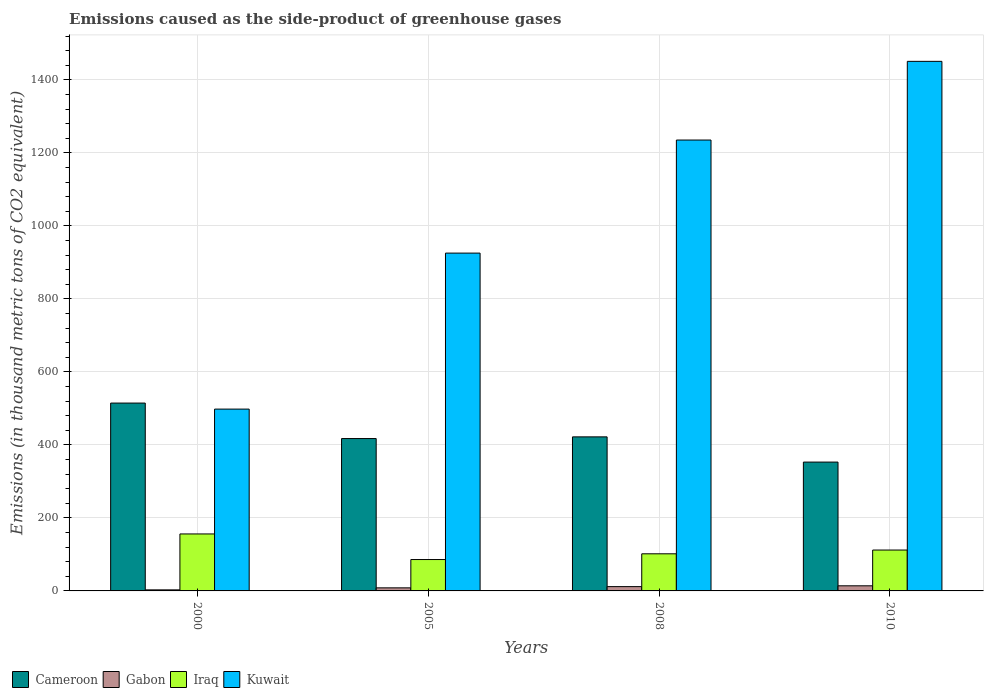How many groups of bars are there?
Make the answer very short. 4. Are the number of bars per tick equal to the number of legend labels?
Offer a very short reply. Yes. Across all years, what is the maximum emissions caused as the side-product of greenhouse gases in Iraq?
Offer a very short reply. 156.1. Across all years, what is the minimum emissions caused as the side-product of greenhouse gases in Cameroon?
Keep it short and to the point. 353. What is the total emissions caused as the side-product of greenhouse gases in Kuwait in the graph?
Your answer should be compact. 4110.2. What is the difference between the emissions caused as the side-product of greenhouse gases in Cameroon in 2008 and that in 2010?
Your response must be concise. 69.1. What is the difference between the emissions caused as the side-product of greenhouse gases in Iraq in 2000 and the emissions caused as the side-product of greenhouse gases in Gabon in 2010?
Provide a succinct answer. 142.1. What is the average emissions caused as the side-product of greenhouse gases in Kuwait per year?
Keep it short and to the point. 1027.55. In the year 2005, what is the difference between the emissions caused as the side-product of greenhouse gases in Iraq and emissions caused as the side-product of greenhouse gases in Kuwait?
Make the answer very short. -839.6. In how many years, is the emissions caused as the side-product of greenhouse gases in Iraq greater than 1280 thousand metric tons?
Your answer should be very brief. 0. What is the ratio of the emissions caused as the side-product of greenhouse gases in Iraq in 2000 to that in 2005?
Offer a terse response. 1.82. Is the emissions caused as the side-product of greenhouse gases in Gabon in 2000 less than that in 2005?
Offer a very short reply. Yes. What is the difference between the highest and the second highest emissions caused as the side-product of greenhouse gases in Gabon?
Ensure brevity in your answer.  2.2. What is the difference between the highest and the lowest emissions caused as the side-product of greenhouse gases in Gabon?
Your answer should be very brief. 11.1. In how many years, is the emissions caused as the side-product of greenhouse gases in Gabon greater than the average emissions caused as the side-product of greenhouse gases in Gabon taken over all years?
Offer a very short reply. 2. Is the sum of the emissions caused as the side-product of greenhouse gases in Iraq in 2000 and 2005 greater than the maximum emissions caused as the side-product of greenhouse gases in Cameroon across all years?
Provide a short and direct response. No. What does the 1st bar from the left in 2000 represents?
Your answer should be very brief. Cameroon. What does the 2nd bar from the right in 2005 represents?
Your answer should be compact. Iraq. How many years are there in the graph?
Your answer should be very brief. 4. Are the values on the major ticks of Y-axis written in scientific E-notation?
Give a very brief answer. No. Does the graph contain grids?
Provide a succinct answer. Yes. How are the legend labels stacked?
Your answer should be compact. Horizontal. What is the title of the graph?
Ensure brevity in your answer.  Emissions caused as the side-product of greenhouse gases. What is the label or title of the X-axis?
Your answer should be compact. Years. What is the label or title of the Y-axis?
Ensure brevity in your answer.  Emissions (in thousand metric tons of CO2 equivalent). What is the Emissions (in thousand metric tons of CO2 equivalent) of Cameroon in 2000?
Your response must be concise. 514.7. What is the Emissions (in thousand metric tons of CO2 equivalent) of Gabon in 2000?
Give a very brief answer. 2.9. What is the Emissions (in thousand metric tons of CO2 equivalent) in Iraq in 2000?
Keep it short and to the point. 156.1. What is the Emissions (in thousand metric tons of CO2 equivalent) of Kuwait in 2000?
Your answer should be very brief. 498.2. What is the Emissions (in thousand metric tons of CO2 equivalent) of Cameroon in 2005?
Keep it short and to the point. 417.5. What is the Emissions (in thousand metric tons of CO2 equivalent) of Gabon in 2005?
Your answer should be compact. 8.4. What is the Emissions (in thousand metric tons of CO2 equivalent) in Kuwait in 2005?
Make the answer very short. 925.6. What is the Emissions (in thousand metric tons of CO2 equivalent) of Cameroon in 2008?
Ensure brevity in your answer.  422.1. What is the Emissions (in thousand metric tons of CO2 equivalent) in Gabon in 2008?
Your answer should be compact. 11.8. What is the Emissions (in thousand metric tons of CO2 equivalent) of Iraq in 2008?
Provide a succinct answer. 101.7. What is the Emissions (in thousand metric tons of CO2 equivalent) of Kuwait in 2008?
Ensure brevity in your answer.  1235.4. What is the Emissions (in thousand metric tons of CO2 equivalent) in Cameroon in 2010?
Offer a very short reply. 353. What is the Emissions (in thousand metric tons of CO2 equivalent) of Iraq in 2010?
Offer a very short reply. 112. What is the Emissions (in thousand metric tons of CO2 equivalent) of Kuwait in 2010?
Make the answer very short. 1451. Across all years, what is the maximum Emissions (in thousand metric tons of CO2 equivalent) in Cameroon?
Offer a very short reply. 514.7. Across all years, what is the maximum Emissions (in thousand metric tons of CO2 equivalent) in Iraq?
Keep it short and to the point. 156.1. Across all years, what is the maximum Emissions (in thousand metric tons of CO2 equivalent) in Kuwait?
Offer a terse response. 1451. Across all years, what is the minimum Emissions (in thousand metric tons of CO2 equivalent) of Cameroon?
Give a very brief answer. 353. Across all years, what is the minimum Emissions (in thousand metric tons of CO2 equivalent) of Iraq?
Offer a terse response. 86. Across all years, what is the minimum Emissions (in thousand metric tons of CO2 equivalent) in Kuwait?
Provide a succinct answer. 498.2. What is the total Emissions (in thousand metric tons of CO2 equivalent) in Cameroon in the graph?
Your response must be concise. 1707.3. What is the total Emissions (in thousand metric tons of CO2 equivalent) in Gabon in the graph?
Ensure brevity in your answer.  37.1. What is the total Emissions (in thousand metric tons of CO2 equivalent) in Iraq in the graph?
Provide a short and direct response. 455.8. What is the total Emissions (in thousand metric tons of CO2 equivalent) in Kuwait in the graph?
Ensure brevity in your answer.  4110.2. What is the difference between the Emissions (in thousand metric tons of CO2 equivalent) of Cameroon in 2000 and that in 2005?
Offer a terse response. 97.2. What is the difference between the Emissions (in thousand metric tons of CO2 equivalent) of Iraq in 2000 and that in 2005?
Your response must be concise. 70.1. What is the difference between the Emissions (in thousand metric tons of CO2 equivalent) in Kuwait in 2000 and that in 2005?
Your answer should be compact. -427.4. What is the difference between the Emissions (in thousand metric tons of CO2 equivalent) in Cameroon in 2000 and that in 2008?
Offer a very short reply. 92.6. What is the difference between the Emissions (in thousand metric tons of CO2 equivalent) of Gabon in 2000 and that in 2008?
Make the answer very short. -8.9. What is the difference between the Emissions (in thousand metric tons of CO2 equivalent) in Iraq in 2000 and that in 2008?
Offer a very short reply. 54.4. What is the difference between the Emissions (in thousand metric tons of CO2 equivalent) of Kuwait in 2000 and that in 2008?
Your answer should be compact. -737.2. What is the difference between the Emissions (in thousand metric tons of CO2 equivalent) in Cameroon in 2000 and that in 2010?
Offer a very short reply. 161.7. What is the difference between the Emissions (in thousand metric tons of CO2 equivalent) in Gabon in 2000 and that in 2010?
Your response must be concise. -11.1. What is the difference between the Emissions (in thousand metric tons of CO2 equivalent) in Iraq in 2000 and that in 2010?
Your response must be concise. 44.1. What is the difference between the Emissions (in thousand metric tons of CO2 equivalent) of Kuwait in 2000 and that in 2010?
Offer a terse response. -952.8. What is the difference between the Emissions (in thousand metric tons of CO2 equivalent) of Cameroon in 2005 and that in 2008?
Give a very brief answer. -4.6. What is the difference between the Emissions (in thousand metric tons of CO2 equivalent) in Iraq in 2005 and that in 2008?
Make the answer very short. -15.7. What is the difference between the Emissions (in thousand metric tons of CO2 equivalent) in Kuwait in 2005 and that in 2008?
Make the answer very short. -309.8. What is the difference between the Emissions (in thousand metric tons of CO2 equivalent) in Cameroon in 2005 and that in 2010?
Make the answer very short. 64.5. What is the difference between the Emissions (in thousand metric tons of CO2 equivalent) of Iraq in 2005 and that in 2010?
Offer a very short reply. -26. What is the difference between the Emissions (in thousand metric tons of CO2 equivalent) in Kuwait in 2005 and that in 2010?
Your response must be concise. -525.4. What is the difference between the Emissions (in thousand metric tons of CO2 equivalent) of Cameroon in 2008 and that in 2010?
Keep it short and to the point. 69.1. What is the difference between the Emissions (in thousand metric tons of CO2 equivalent) in Gabon in 2008 and that in 2010?
Your response must be concise. -2.2. What is the difference between the Emissions (in thousand metric tons of CO2 equivalent) of Kuwait in 2008 and that in 2010?
Give a very brief answer. -215.6. What is the difference between the Emissions (in thousand metric tons of CO2 equivalent) in Cameroon in 2000 and the Emissions (in thousand metric tons of CO2 equivalent) in Gabon in 2005?
Ensure brevity in your answer.  506.3. What is the difference between the Emissions (in thousand metric tons of CO2 equivalent) of Cameroon in 2000 and the Emissions (in thousand metric tons of CO2 equivalent) of Iraq in 2005?
Offer a very short reply. 428.7. What is the difference between the Emissions (in thousand metric tons of CO2 equivalent) in Cameroon in 2000 and the Emissions (in thousand metric tons of CO2 equivalent) in Kuwait in 2005?
Your answer should be compact. -410.9. What is the difference between the Emissions (in thousand metric tons of CO2 equivalent) of Gabon in 2000 and the Emissions (in thousand metric tons of CO2 equivalent) of Iraq in 2005?
Make the answer very short. -83.1. What is the difference between the Emissions (in thousand metric tons of CO2 equivalent) in Gabon in 2000 and the Emissions (in thousand metric tons of CO2 equivalent) in Kuwait in 2005?
Offer a very short reply. -922.7. What is the difference between the Emissions (in thousand metric tons of CO2 equivalent) of Iraq in 2000 and the Emissions (in thousand metric tons of CO2 equivalent) of Kuwait in 2005?
Provide a short and direct response. -769.5. What is the difference between the Emissions (in thousand metric tons of CO2 equivalent) of Cameroon in 2000 and the Emissions (in thousand metric tons of CO2 equivalent) of Gabon in 2008?
Your answer should be compact. 502.9. What is the difference between the Emissions (in thousand metric tons of CO2 equivalent) of Cameroon in 2000 and the Emissions (in thousand metric tons of CO2 equivalent) of Iraq in 2008?
Your answer should be very brief. 413. What is the difference between the Emissions (in thousand metric tons of CO2 equivalent) in Cameroon in 2000 and the Emissions (in thousand metric tons of CO2 equivalent) in Kuwait in 2008?
Make the answer very short. -720.7. What is the difference between the Emissions (in thousand metric tons of CO2 equivalent) in Gabon in 2000 and the Emissions (in thousand metric tons of CO2 equivalent) in Iraq in 2008?
Your answer should be very brief. -98.8. What is the difference between the Emissions (in thousand metric tons of CO2 equivalent) of Gabon in 2000 and the Emissions (in thousand metric tons of CO2 equivalent) of Kuwait in 2008?
Keep it short and to the point. -1232.5. What is the difference between the Emissions (in thousand metric tons of CO2 equivalent) in Iraq in 2000 and the Emissions (in thousand metric tons of CO2 equivalent) in Kuwait in 2008?
Your response must be concise. -1079.3. What is the difference between the Emissions (in thousand metric tons of CO2 equivalent) of Cameroon in 2000 and the Emissions (in thousand metric tons of CO2 equivalent) of Gabon in 2010?
Provide a succinct answer. 500.7. What is the difference between the Emissions (in thousand metric tons of CO2 equivalent) in Cameroon in 2000 and the Emissions (in thousand metric tons of CO2 equivalent) in Iraq in 2010?
Keep it short and to the point. 402.7. What is the difference between the Emissions (in thousand metric tons of CO2 equivalent) of Cameroon in 2000 and the Emissions (in thousand metric tons of CO2 equivalent) of Kuwait in 2010?
Your answer should be very brief. -936.3. What is the difference between the Emissions (in thousand metric tons of CO2 equivalent) in Gabon in 2000 and the Emissions (in thousand metric tons of CO2 equivalent) in Iraq in 2010?
Provide a succinct answer. -109.1. What is the difference between the Emissions (in thousand metric tons of CO2 equivalent) of Gabon in 2000 and the Emissions (in thousand metric tons of CO2 equivalent) of Kuwait in 2010?
Offer a terse response. -1448.1. What is the difference between the Emissions (in thousand metric tons of CO2 equivalent) of Iraq in 2000 and the Emissions (in thousand metric tons of CO2 equivalent) of Kuwait in 2010?
Ensure brevity in your answer.  -1294.9. What is the difference between the Emissions (in thousand metric tons of CO2 equivalent) in Cameroon in 2005 and the Emissions (in thousand metric tons of CO2 equivalent) in Gabon in 2008?
Offer a terse response. 405.7. What is the difference between the Emissions (in thousand metric tons of CO2 equivalent) of Cameroon in 2005 and the Emissions (in thousand metric tons of CO2 equivalent) of Iraq in 2008?
Offer a very short reply. 315.8. What is the difference between the Emissions (in thousand metric tons of CO2 equivalent) in Cameroon in 2005 and the Emissions (in thousand metric tons of CO2 equivalent) in Kuwait in 2008?
Your answer should be compact. -817.9. What is the difference between the Emissions (in thousand metric tons of CO2 equivalent) in Gabon in 2005 and the Emissions (in thousand metric tons of CO2 equivalent) in Iraq in 2008?
Provide a succinct answer. -93.3. What is the difference between the Emissions (in thousand metric tons of CO2 equivalent) in Gabon in 2005 and the Emissions (in thousand metric tons of CO2 equivalent) in Kuwait in 2008?
Your answer should be compact. -1227. What is the difference between the Emissions (in thousand metric tons of CO2 equivalent) of Iraq in 2005 and the Emissions (in thousand metric tons of CO2 equivalent) of Kuwait in 2008?
Your answer should be very brief. -1149.4. What is the difference between the Emissions (in thousand metric tons of CO2 equivalent) of Cameroon in 2005 and the Emissions (in thousand metric tons of CO2 equivalent) of Gabon in 2010?
Your answer should be compact. 403.5. What is the difference between the Emissions (in thousand metric tons of CO2 equivalent) in Cameroon in 2005 and the Emissions (in thousand metric tons of CO2 equivalent) in Iraq in 2010?
Make the answer very short. 305.5. What is the difference between the Emissions (in thousand metric tons of CO2 equivalent) of Cameroon in 2005 and the Emissions (in thousand metric tons of CO2 equivalent) of Kuwait in 2010?
Your answer should be compact. -1033.5. What is the difference between the Emissions (in thousand metric tons of CO2 equivalent) of Gabon in 2005 and the Emissions (in thousand metric tons of CO2 equivalent) of Iraq in 2010?
Your answer should be very brief. -103.6. What is the difference between the Emissions (in thousand metric tons of CO2 equivalent) in Gabon in 2005 and the Emissions (in thousand metric tons of CO2 equivalent) in Kuwait in 2010?
Offer a very short reply. -1442.6. What is the difference between the Emissions (in thousand metric tons of CO2 equivalent) of Iraq in 2005 and the Emissions (in thousand metric tons of CO2 equivalent) of Kuwait in 2010?
Provide a short and direct response. -1365. What is the difference between the Emissions (in thousand metric tons of CO2 equivalent) in Cameroon in 2008 and the Emissions (in thousand metric tons of CO2 equivalent) in Gabon in 2010?
Keep it short and to the point. 408.1. What is the difference between the Emissions (in thousand metric tons of CO2 equivalent) in Cameroon in 2008 and the Emissions (in thousand metric tons of CO2 equivalent) in Iraq in 2010?
Your answer should be compact. 310.1. What is the difference between the Emissions (in thousand metric tons of CO2 equivalent) of Cameroon in 2008 and the Emissions (in thousand metric tons of CO2 equivalent) of Kuwait in 2010?
Provide a succinct answer. -1028.9. What is the difference between the Emissions (in thousand metric tons of CO2 equivalent) in Gabon in 2008 and the Emissions (in thousand metric tons of CO2 equivalent) in Iraq in 2010?
Your answer should be compact. -100.2. What is the difference between the Emissions (in thousand metric tons of CO2 equivalent) in Gabon in 2008 and the Emissions (in thousand metric tons of CO2 equivalent) in Kuwait in 2010?
Offer a terse response. -1439.2. What is the difference between the Emissions (in thousand metric tons of CO2 equivalent) of Iraq in 2008 and the Emissions (in thousand metric tons of CO2 equivalent) of Kuwait in 2010?
Provide a short and direct response. -1349.3. What is the average Emissions (in thousand metric tons of CO2 equivalent) of Cameroon per year?
Your response must be concise. 426.82. What is the average Emissions (in thousand metric tons of CO2 equivalent) in Gabon per year?
Keep it short and to the point. 9.28. What is the average Emissions (in thousand metric tons of CO2 equivalent) in Iraq per year?
Ensure brevity in your answer.  113.95. What is the average Emissions (in thousand metric tons of CO2 equivalent) in Kuwait per year?
Keep it short and to the point. 1027.55. In the year 2000, what is the difference between the Emissions (in thousand metric tons of CO2 equivalent) of Cameroon and Emissions (in thousand metric tons of CO2 equivalent) of Gabon?
Your response must be concise. 511.8. In the year 2000, what is the difference between the Emissions (in thousand metric tons of CO2 equivalent) of Cameroon and Emissions (in thousand metric tons of CO2 equivalent) of Iraq?
Ensure brevity in your answer.  358.6. In the year 2000, what is the difference between the Emissions (in thousand metric tons of CO2 equivalent) of Cameroon and Emissions (in thousand metric tons of CO2 equivalent) of Kuwait?
Ensure brevity in your answer.  16.5. In the year 2000, what is the difference between the Emissions (in thousand metric tons of CO2 equivalent) in Gabon and Emissions (in thousand metric tons of CO2 equivalent) in Iraq?
Your answer should be very brief. -153.2. In the year 2000, what is the difference between the Emissions (in thousand metric tons of CO2 equivalent) of Gabon and Emissions (in thousand metric tons of CO2 equivalent) of Kuwait?
Your answer should be compact. -495.3. In the year 2000, what is the difference between the Emissions (in thousand metric tons of CO2 equivalent) of Iraq and Emissions (in thousand metric tons of CO2 equivalent) of Kuwait?
Keep it short and to the point. -342.1. In the year 2005, what is the difference between the Emissions (in thousand metric tons of CO2 equivalent) of Cameroon and Emissions (in thousand metric tons of CO2 equivalent) of Gabon?
Provide a short and direct response. 409.1. In the year 2005, what is the difference between the Emissions (in thousand metric tons of CO2 equivalent) of Cameroon and Emissions (in thousand metric tons of CO2 equivalent) of Iraq?
Your answer should be very brief. 331.5. In the year 2005, what is the difference between the Emissions (in thousand metric tons of CO2 equivalent) in Cameroon and Emissions (in thousand metric tons of CO2 equivalent) in Kuwait?
Offer a terse response. -508.1. In the year 2005, what is the difference between the Emissions (in thousand metric tons of CO2 equivalent) in Gabon and Emissions (in thousand metric tons of CO2 equivalent) in Iraq?
Give a very brief answer. -77.6. In the year 2005, what is the difference between the Emissions (in thousand metric tons of CO2 equivalent) of Gabon and Emissions (in thousand metric tons of CO2 equivalent) of Kuwait?
Provide a short and direct response. -917.2. In the year 2005, what is the difference between the Emissions (in thousand metric tons of CO2 equivalent) in Iraq and Emissions (in thousand metric tons of CO2 equivalent) in Kuwait?
Your response must be concise. -839.6. In the year 2008, what is the difference between the Emissions (in thousand metric tons of CO2 equivalent) of Cameroon and Emissions (in thousand metric tons of CO2 equivalent) of Gabon?
Give a very brief answer. 410.3. In the year 2008, what is the difference between the Emissions (in thousand metric tons of CO2 equivalent) of Cameroon and Emissions (in thousand metric tons of CO2 equivalent) of Iraq?
Your response must be concise. 320.4. In the year 2008, what is the difference between the Emissions (in thousand metric tons of CO2 equivalent) in Cameroon and Emissions (in thousand metric tons of CO2 equivalent) in Kuwait?
Ensure brevity in your answer.  -813.3. In the year 2008, what is the difference between the Emissions (in thousand metric tons of CO2 equivalent) of Gabon and Emissions (in thousand metric tons of CO2 equivalent) of Iraq?
Offer a terse response. -89.9. In the year 2008, what is the difference between the Emissions (in thousand metric tons of CO2 equivalent) in Gabon and Emissions (in thousand metric tons of CO2 equivalent) in Kuwait?
Keep it short and to the point. -1223.6. In the year 2008, what is the difference between the Emissions (in thousand metric tons of CO2 equivalent) in Iraq and Emissions (in thousand metric tons of CO2 equivalent) in Kuwait?
Provide a short and direct response. -1133.7. In the year 2010, what is the difference between the Emissions (in thousand metric tons of CO2 equivalent) in Cameroon and Emissions (in thousand metric tons of CO2 equivalent) in Gabon?
Keep it short and to the point. 339. In the year 2010, what is the difference between the Emissions (in thousand metric tons of CO2 equivalent) of Cameroon and Emissions (in thousand metric tons of CO2 equivalent) of Iraq?
Make the answer very short. 241. In the year 2010, what is the difference between the Emissions (in thousand metric tons of CO2 equivalent) in Cameroon and Emissions (in thousand metric tons of CO2 equivalent) in Kuwait?
Offer a terse response. -1098. In the year 2010, what is the difference between the Emissions (in thousand metric tons of CO2 equivalent) in Gabon and Emissions (in thousand metric tons of CO2 equivalent) in Iraq?
Give a very brief answer. -98. In the year 2010, what is the difference between the Emissions (in thousand metric tons of CO2 equivalent) in Gabon and Emissions (in thousand metric tons of CO2 equivalent) in Kuwait?
Provide a short and direct response. -1437. In the year 2010, what is the difference between the Emissions (in thousand metric tons of CO2 equivalent) in Iraq and Emissions (in thousand metric tons of CO2 equivalent) in Kuwait?
Give a very brief answer. -1339. What is the ratio of the Emissions (in thousand metric tons of CO2 equivalent) of Cameroon in 2000 to that in 2005?
Provide a succinct answer. 1.23. What is the ratio of the Emissions (in thousand metric tons of CO2 equivalent) in Gabon in 2000 to that in 2005?
Your response must be concise. 0.35. What is the ratio of the Emissions (in thousand metric tons of CO2 equivalent) in Iraq in 2000 to that in 2005?
Your answer should be very brief. 1.82. What is the ratio of the Emissions (in thousand metric tons of CO2 equivalent) in Kuwait in 2000 to that in 2005?
Offer a very short reply. 0.54. What is the ratio of the Emissions (in thousand metric tons of CO2 equivalent) in Cameroon in 2000 to that in 2008?
Provide a succinct answer. 1.22. What is the ratio of the Emissions (in thousand metric tons of CO2 equivalent) of Gabon in 2000 to that in 2008?
Your answer should be very brief. 0.25. What is the ratio of the Emissions (in thousand metric tons of CO2 equivalent) of Iraq in 2000 to that in 2008?
Ensure brevity in your answer.  1.53. What is the ratio of the Emissions (in thousand metric tons of CO2 equivalent) of Kuwait in 2000 to that in 2008?
Give a very brief answer. 0.4. What is the ratio of the Emissions (in thousand metric tons of CO2 equivalent) of Cameroon in 2000 to that in 2010?
Make the answer very short. 1.46. What is the ratio of the Emissions (in thousand metric tons of CO2 equivalent) of Gabon in 2000 to that in 2010?
Ensure brevity in your answer.  0.21. What is the ratio of the Emissions (in thousand metric tons of CO2 equivalent) of Iraq in 2000 to that in 2010?
Provide a succinct answer. 1.39. What is the ratio of the Emissions (in thousand metric tons of CO2 equivalent) of Kuwait in 2000 to that in 2010?
Provide a short and direct response. 0.34. What is the ratio of the Emissions (in thousand metric tons of CO2 equivalent) of Gabon in 2005 to that in 2008?
Provide a succinct answer. 0.71. What is the ratio of the Emissions (in thousand metric tons of CO2 equivalent) of Iraq in 2005 to that in 2008?
Provide a short and direct response. 0.85. What is the ratio of the Emissions (in thousand metric tons of CO2 equivalent) of Kuwait in 2005 to that in 2008?
Your response must be concise. 0.75. What is the ratio of the Emissions (in thousand metric tons of CO2 equivalent) in Cameroon in 2005 to that in 2010?
Offer a terse response. 1.18. What is the ratio of the Emissions (in thousand metric tons of CO2 equivalent) in Gabon in 2005 to that in 2010?
Provide a short and direct response. 0.6. What is the ratio of the Emissions (in thousand metric tons of CO2 equivalent) in Iraq in 2005 to that in 2010?
Offer a terse response. 0.77. What is the ratio of the Emissions (in thousand metric tons of CO2 equivalent) of Kuwait in 2005 to that in 2010?
Your answer should be compact. 0.64. What is the ratio of the Emissions (in thousand metric tons of CO2 equivalent) in Cameroon in 2008 to that in 2010?
Provide a short and direct response. 1.2. What is the ratio of the Emissions (in thousand metric tons of CO2 equivalent) in Gabon in 2008 to that in 2010?
Offer a terse response. 0.84. What is the ratio of the Emissions (in thousand metric tons of CO2 equivalent) in Iraq in 2008 to that in 2010?
Provide a short and direct response. 0.91. What is the ratio of the Emissions (in thousand metric tons of CO2 equivalent) of Kuwait in 2008 to that in 2010?
Your answer should be compact. 0.85. What is the difference between the highest and the second highest Emissions (in thousand metric tons of CO2 equivalent) of Cameroon?
Make the answer very short. 92.6. What is the difference between the highest and the second highest Emissions (in thousand metric tons of CO2 equivalent) of Iraq?
Offer a very short reply. 44.1. What is the difference between the highest and the second highest Emissions (in thousand metric tons of CO2 equivalent) in Kuwait?
Your response must be concise. 215.6. What is the difference between the highest and the lowest Emissions (in thousand metric tons of CO2 equivalent) in Cameroon?
Offer a very short reply. 161.7. What is the difference between the highest and the lowest Emissions (in thousand metric tons of CO2 equivalent) in Iraq?
Keep it short and to the point. 70.1. What is the difference between the highest and the lowest Emissions (in thousand metric tons of CO2 equivalent) of Kuwait?
Provide a short and direct response. 952.8. 